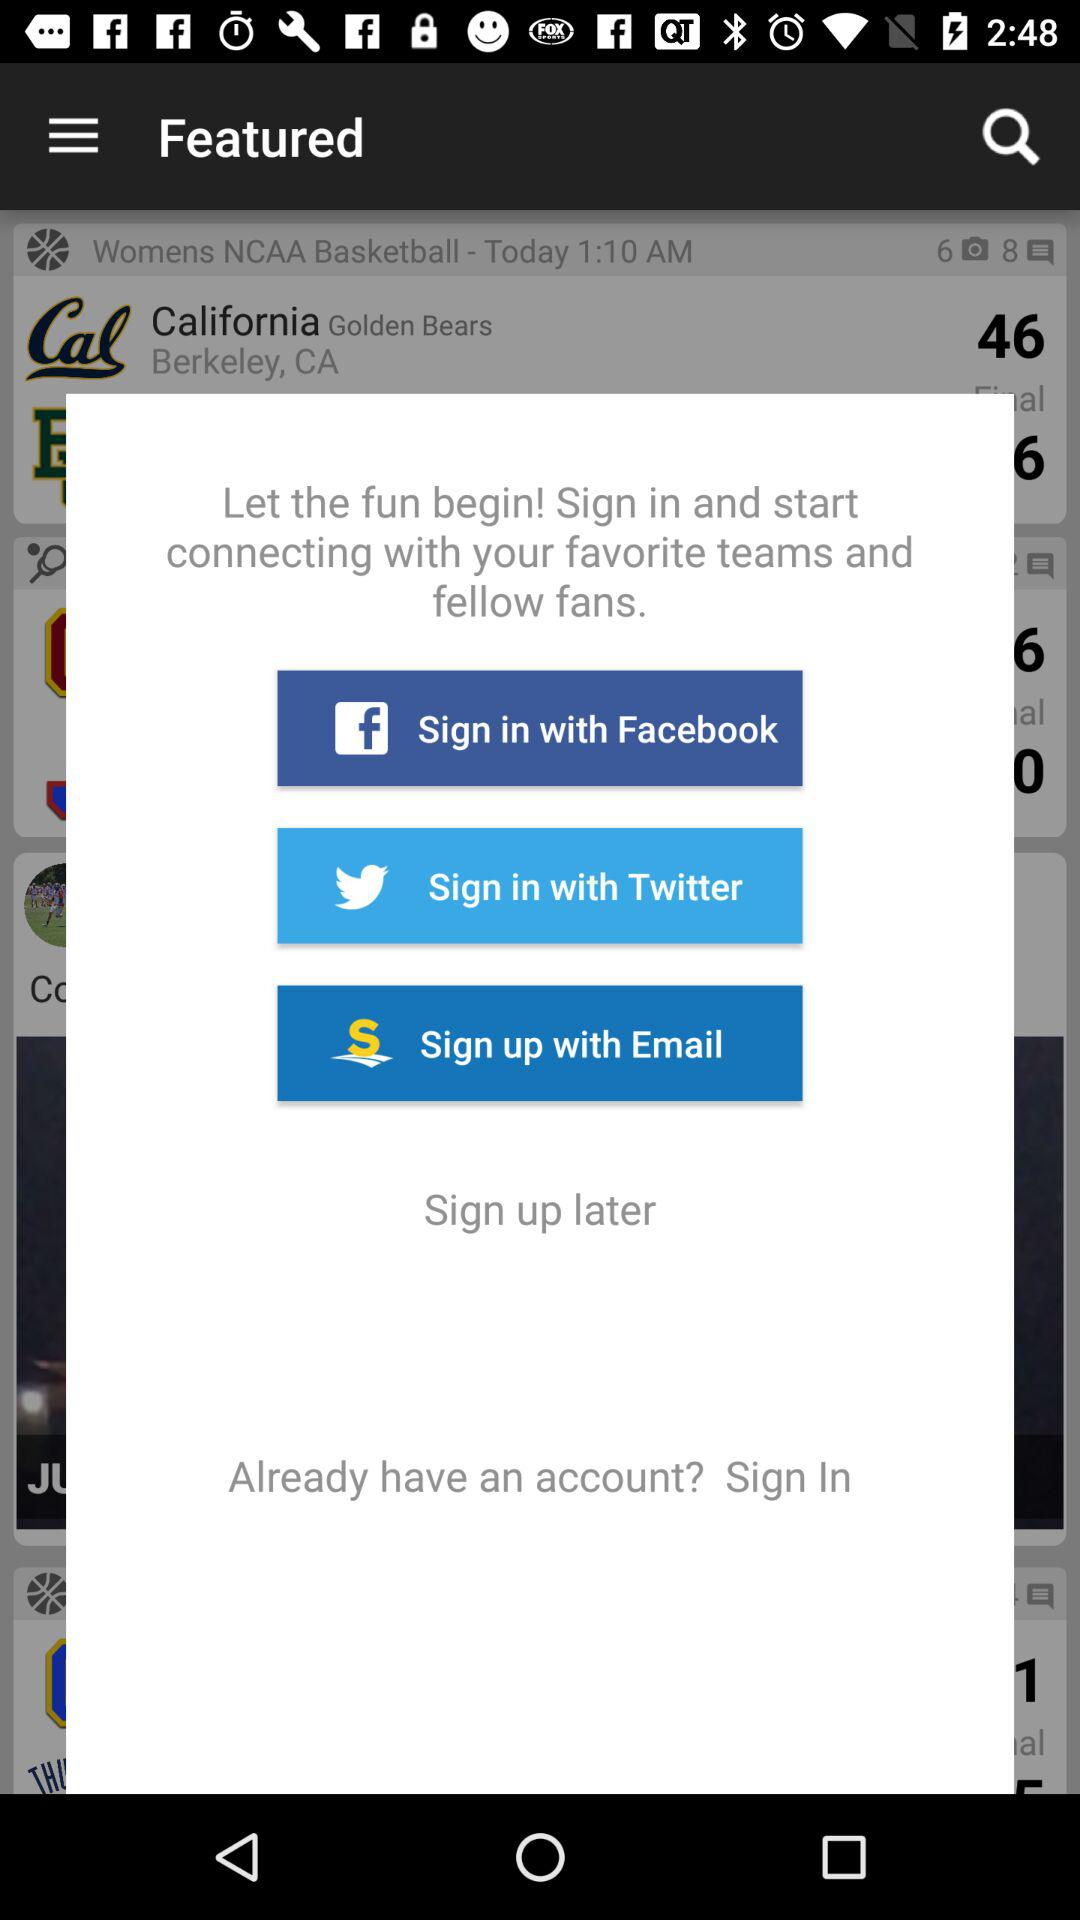How many sign in options are there?
Answer the question using a single word or phrase. 3 